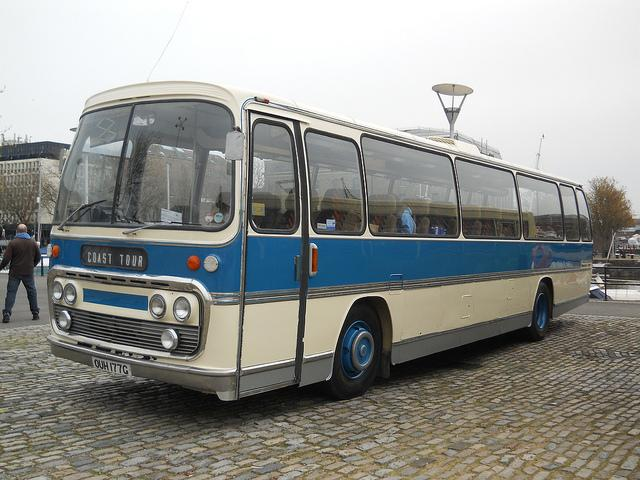What service is being offered for riders on the blue and white bus?

Choices:
A) tours
B) haircuts
C) healthcare
D) buffets tours 